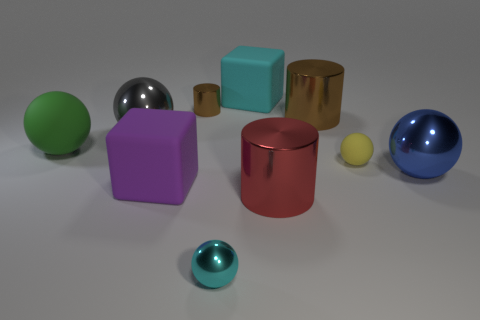Subtract all green spheres. How many spheres are left? 4 Subtract all yellow spheres. How many spheres are left? 4 Subtract 2 spheres. How many spheres are left? 3 Subtract all blue cylinders. Subtract all brown balls. How many cylinders are left? 3 Subtract all blocks. How many objects are left? 8 Subtract all small cyan things. Subtract all big gray things. How many objects are left? 8 Add 2 large brown objects. How many large brown objects are left? 3 Add 5 small yellow matte objects. How many small yellow matte objects exist? 6 Subtract 1 red cylinders. How many objects are left? 9 